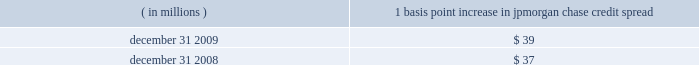Management 2019s discussion and analysis jpmorgan chase & co./2009 annual report 130 the following histogram illustrates the daily market risk 2013related gains and losses for ib and consumer/cio positions for 2009 .
The chart shows that the firm posted market risk 2013related gains on 227 out of 261 days in this period , with 69 days exceeding $ 160 million .
The inset graph looks at those days on which the firm experienced losses and depicts the amount by which the 95% ( 95 % ) confidence level var exceeded the actual loss on each of those days .
Losses were sustained on 34 days during 2009 and exceeded the var measure on one day due to high market volatility in the first quarter of 2009 .
Under the 95% ( 95 % ) confidence interval , the firm would expect to incur daily losses greater than that pre- dicted by var estimates about twelve times a year .
The table provides information about the gross sensitivity of dva to a one-basis-point increase in jpmorgan chase 2019s credit spreads .
This sensitivity represents the impact from a one-basis-point parallel shift in jpmorgan chase 2019s entire credit curve .
As credit curves do not typically move in a parallel fashion , the sensitivity multiplied by the change in spreads at a single maturity point may not be representative of the actual revenue recognized .
Debit valuation adjustment sensitivity 1 basis point increase in ( in millions ) jpmorgan chase credit spread .
Loss advisories and drawdowns loss advisories and drawdowns are tools used to highlight to senior management trading losses above certain levels and initiate discus- sion of remedies .
Economic value stress testing while var reflects the risk of loss due to adverse changes in normal markets , stress testing captures the firm 2019s exposure to unlikely but plausible events in abnormal markets .
The firm conducts economic- value stress tests using multiple scenarios that assume credit spreads widen significantly , equity prices decline and significant changes in interest rates across the major currencies .
Other scenar- ios focus on the risks predominant in individual business segments and include scenarios that focus on the potential for adverse movements in complex portfolios .
Scenarios were updated more frequently in 2009 and , in some cases , redefined to reflect the signifi- cant market volatility which began in late 2008 .
Along with var , stress testing is important in measuring and controlling risk .
Stress testing enhances the understanding of the firm 2019s risk profile and loss potential , and stress losses are monitored against limits .
Stress testing is also utilized in one-off approvals and cross-business risk measurement , as well as an input to economic capital allocation .
Stress-test results , trends and explanations based on current market risk positions are reported to the firm 2019s senior management and to the lines of business to help them better measure and manage risks and to understand event risk 2013sensitive positions. .
What is the fluctuation of the credit spread in 2008 and 2009 , in basis points? 
Rationale: its the percentual difference multiplied by the 100 basis points .
Computations: (((39 / 37) - 1) * 100)
Answer: 5.40541. Management 2019s discussion and analysis jpmorgan chase & co./2009 annual report 130 the following histogram illustrates the daily market risk 2013related gains and losses for ib and consumer/cio positions for 2009 .
The chart shows that the firm posted market risk 2013related gains on 227 out of 261 days in this period , with 69 days exceeding $ 160 million .
The inset graph looks at those days on which the firm experienced losses and depicts the amount by which the 95% ( 95 % ) confidence level var exceeded the actual loss on each of those days .
Losses were sustained on 34 days during 2009 and exceeded the var measure on one day due to high market volatility in the first quarter of 2009 .
Under the 95% ( 95 % ) confidence interval , the firm would expect to incur daily losses greater than that pre- dicted by var estimates about twelve times a year .
The table provides information about the gross sensitivity of dva to a one-basis-point increase in jpmorgan chase 2019s credit spreads .
This sensitivity represents the impact from a one-basis-point parallel shift in jpmorgan chase 2019s entire credit curve .
As credit curves do not typically move in a parallel fashion , the sensitivity multiplied by the change in spreads at a single maturity point may not be representative of the actual revenue recognized .
Debit valuation adjustment sensitivity 1 basis point increase in ( in millions ) jpmorgan chase credit spread .
Loss advisories and drawdowns loss advisories and drawdowns are tools used to highlight to senior management trading losses above certain levels and initiate discus- sion of remedies .
Economic value stress testing while var reflects the risk of loss due to adverse changes in normal markets , stress testing captures the firm 2019s exposure to unlikely but plausible events in abnormal markets .
The firm conducts economic- value stress tests using multiple scenarios that assume credit spreads widen significantly , equity prices decline and significant changes in interest rates across the major currencies .
Other scenar- ios focus on the risks predominant in individual business segments and include scenarios that focus on the potential for adverse movements in complex portfolios .
Scenarios were updated more frequently in 2009 and , in some cases , redefined to reflect the signifi- cant market volatility which began in late 2008 .
Along with var , stress testing is important in measuring and controlling risk .
Stress testing enhances the understanding of the firm 2019s risk profile and loss potential , and stress losses are monitored against limits .
Stress testing is also utilized in one-off approvals and cross-business risk measurement , as well as an input to economic capital allocation .
Stress-test results , trends and explanations based on current market risk positions are reported to the firm 2019s senior management and to the lines of business to help them better measure and manage risks and to understand event risk 2013sensitive positions. .
What is the increase observed in the credit spread between 2008 and 2009 , in millions of dollars? 
Rationale: its the difference between the 2008's credit spread and the 2009's credit spread .
Computations: (39 - 37)
Answer: 2.0. Management 2019s discussion and analysis jpmorgan chase & co./2009 annual report 130 the following histogram illustrates the daily market risk 2013related gains and losses for ib and consumer/cio positions for 2009 .
The chart shows that the firm posted market risk 2013related gains on 227 out of 261 days in this period , with 69 days exceeding $ 160 million .
The inset graph looks at those days on which the firm experienced losses and depicts the amount by which the 95% ( 95 % ) confidence level var exceeded the actual loss on each of those days .
Losses were sustained on 34 days during 2009 and exceeded the var measure on one day due to high market volatility in the first quarter of 2009 .
Under the 95% ( 95 % ) confidence interval , the firm would expect to incur daily losses greater than that pre- dicted by var estimates about twelve times a year .
The table provides information about the gross sensitivity of dva to a one-basis-point increase in jpmorgan chase 2019s credit spreads .
This sensitivity represents the impact from a one-basis-point parallel shift in jpmorgan chase 2019s entire credit curve .
As credit curves do not typically move in a parallel fashion , the sensitivity multiplied by the change in spreads at a single maturity point may not be representative of the actual revenue recognized .
Debit valuation adjustment sensitivity 1 basis point increase in ( in millions ) jpmorgan chase credit spread .
Loss advisories and drawdowns loss advisories and drawdowns are tools used to highlight to senior management trading losses above certain levels and initiate discus- sion of remedies .
Economic value stress testing while var reflects the risk of loss due to adverse changes in normal markets , stress testing captures the firm 2019s exposure to unlikely but plausible events in abnormal markets .
The firm conducts economic- value stress tests using multiple scenarios that assume credit spreads widen significantly , equity prices decline and significant changes in interest rates across the major currencies .
Other scenar- ios focus on the risks predominant in individual business segments and include scenarios that focus on the potential for adverse movements in complex portfolios .
Scenarios were updated more frequently in 2009 and , in some cases , redefined to reflect the signifi- cant market volatility which began in late 2008 .
Along with var , stress testing is important in measuring and controlling risk .
Stress testing enhances the understanding of the firm 2019s risk profile and loss potential , and stress losses are monitored against limits .
Stress testing is also utilized in one-off approvals and cross-business risk measurement , as well as an input to economic capital allocation .
Stress-test results , trends and explanations based on current market risk positions are reported to the firm 2019s senior management and to the lines of business to help them better measure and manage risks and to understand event risk 2013sensitive positions. .
On what percent of trading days did the firm have market risk 2013related losses? 
Computations: ((261 - 227) / 261)
Answer: 0.13027. 